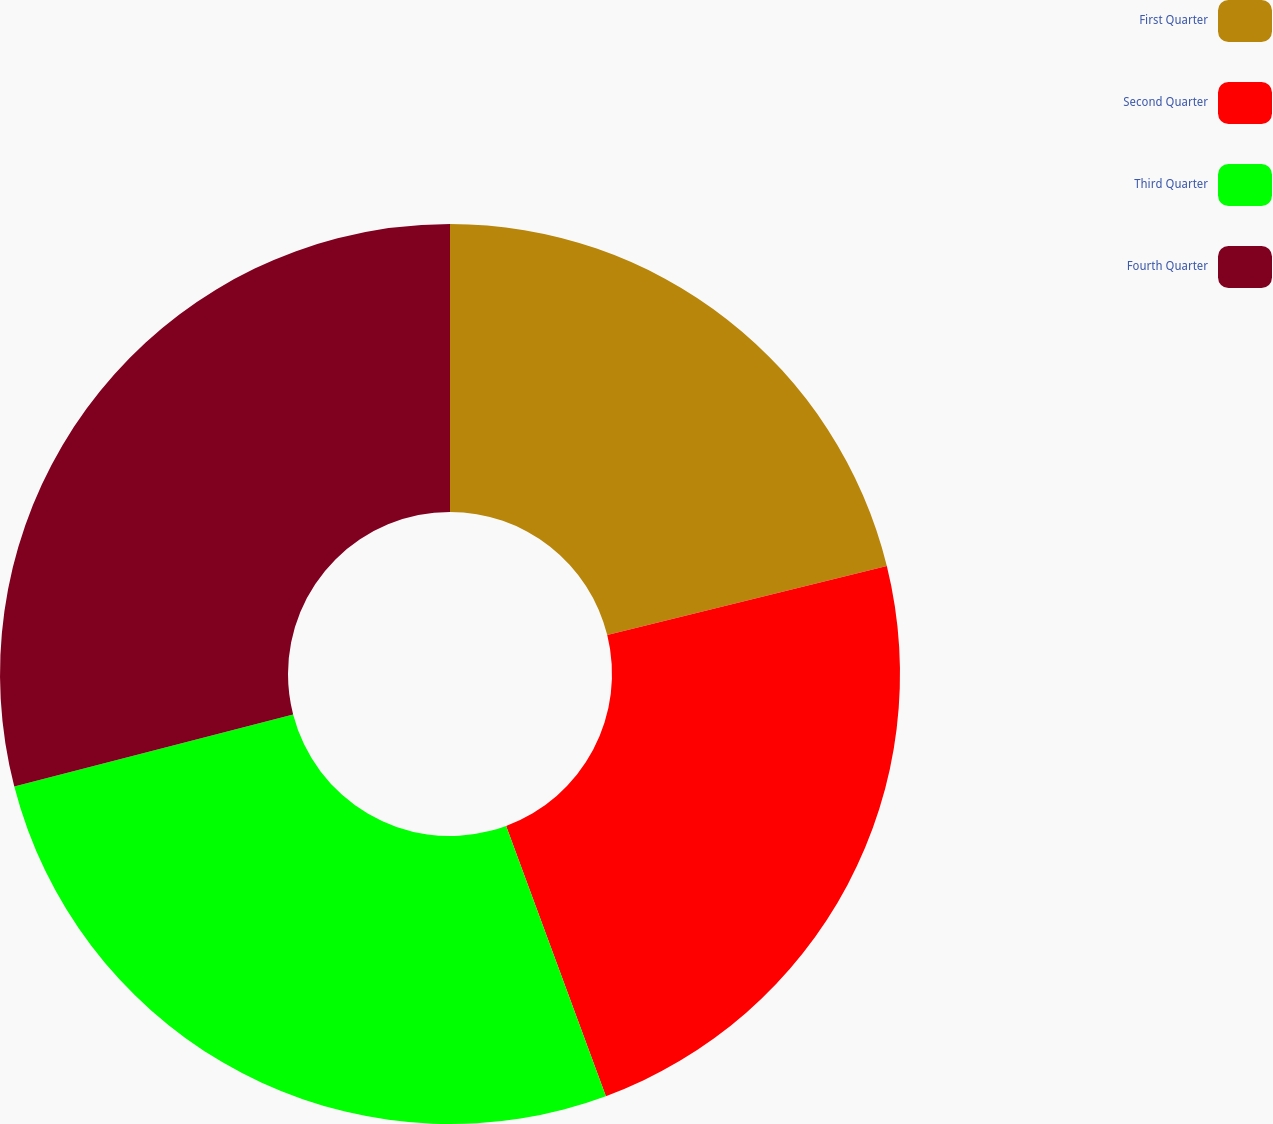<chart> <loc_0><loc_0><loc_500><loc_500><pie_chart><fcel>First Quarter<fcel>Second Quarter<fcel>Third Quarter<fcel>Fourth Quarter<nl><fcel>21.14%<fcel>23.23%<fcel>26.61%<fcel>29.02%<nl></chart> 